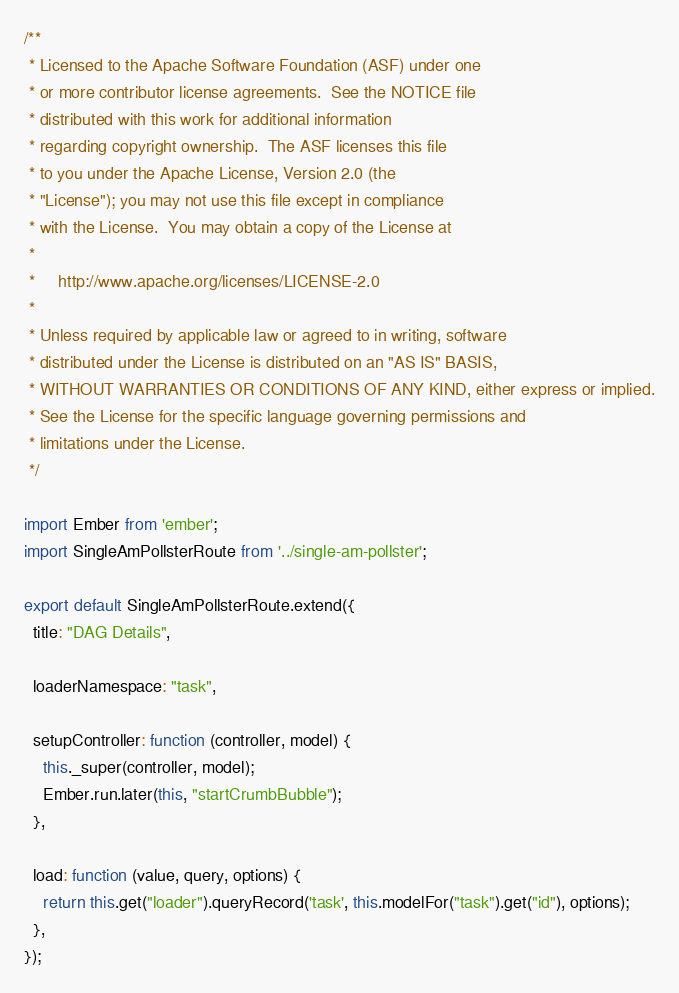Convert code to text. <code><loc_0><loc_0><loc_500><loc_500><_JavaScript_>/**
 * Licensed to the Apache Software Foundation (ASF) under one
 * or more contributor license agreements.  See the NOTICE file
 * distributed with this work for additional information
 * regarding copyright ownership.  The ASF licenses this file
 * to you under the Apache License, Version 2.0 (the
 * "License"); you may not use this file except in compliance
 * with the License.  You may obtain a copy of the License at
 *
 *     http://www.apache.org/licenses/LICENSE-2.0
 *
 * Unless required by applicable law or agreed to in writing, software
 * distributed under the License is distributed on an "AS IS" BASIS,
 * WITHOUT WARRANTIES OR CONDITIONS OF ANY KIND, either express or implied.
 * See the License for the specific language governing permissions and
 * limitations under the License.
 */

import Ember from 'ember';
import SingleAmPollsterRoute from '../single-am-pollster';

export default SingleAmPollsterRoute.extend({
  title: "DAG Details",

  loaderNamespace: "task",

  setupController: function (controller, model) {
    this._super(controller, model);
    Ember.run.later(this, "startCrumbBubble");
  },

  load: function (value, query, options) {
    return this.get("loader").queryRecord('task', this.modelFor("task").get("id"), options);
  },
});
</code> 